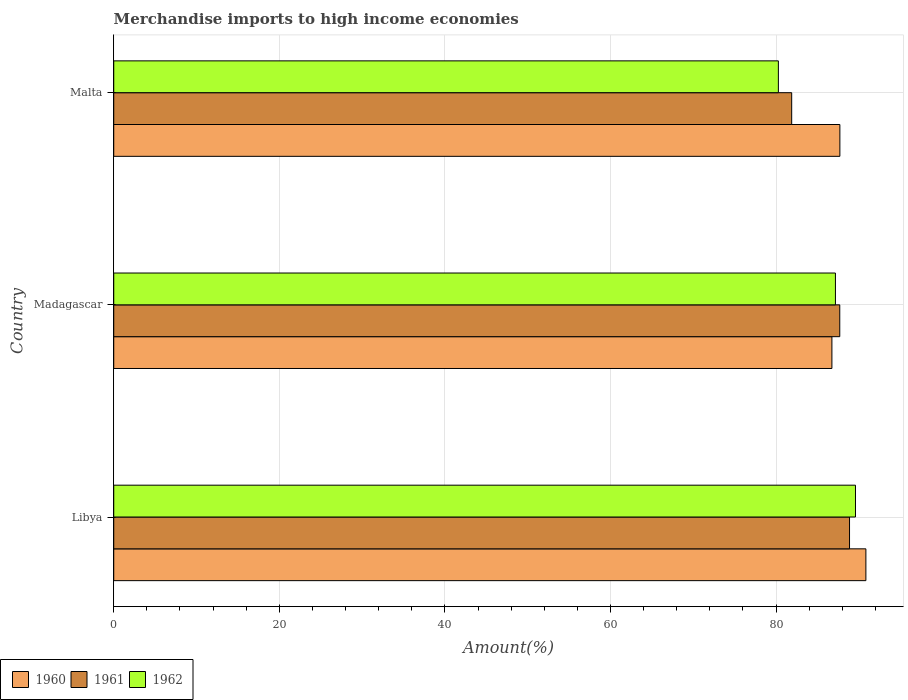Are the number of bars per tick equal to the number of legend labels?
Make the answer very short. Yes. Are the number of bars on each tick of the Y-axis equal?
Your answer should be compact. Yes. How many bars are there on the 2nd tick from the bottom?
Offer a very short reply. 3. What is the label of the 2nd group of bars from the top?
Your answer should be very brief. Madagascar. In how many cases, is the number of bars for a given country not equal to the number of legend labels?
Offer a very short reply. 0. What is the percentage of amount earned from merchandise imports in 1962 in Malta?
Make the answer very short. 80.28. Across all countries, what is the maximum percentage of amount earned from merchandise imports in 1961?
Offer a very short reply. 88.87. Across all countries, what is the minimum percentage of amount earned from merchandise imports in 1962?
Provide a short and direct response. 80.28. In which country was the percentage of amount earned from merchandise imports in 1960 maximum?
Keep it short and to the point. Libya. In which country was the percentage of amount earned from merchandise imports in 1961 minimum?
Make the answer very short. Malta. What is the total percentage of amount earned from merchandise imports in 1962 in the graph?
Offer a very short reply. 257.04. What is the difference between the percentage of amount earned from merchandise imports in 1960 in Libya and that in Malta?
Make the answer very short. 3.14. What is the difference between the percentage of amount earned from merchandise imports in 1960 in Malta and the percentage of amount earned from merchandise imports in 1962 in Libya?
Ensure brevity in your answer.  -1.88. What is the average percentage of amount earned from merchandise imports in 1961 per country?
Your response must be concise. 86.15. What is the difference between the percentage of amount earned from merchandise imports in 1960 and percentage of amount earned from merchandise imports in 1961 in Madagascar?
Ensure brevity in your answer.  -0.95. What is the ratio of the percentage of amount earned from merchandise imports in 1960 in Libya to that in Malta?
Your answer should be compact. 1.04. Is the percentage of amount earned from merchandise imports in 1960 in Libya less than that in Madagascar?
Ensure brevity in your answer.  No. What is the difference between the highest and the second highest percentage of amount earned from merchandise imports in 1961?
Make the answer very short. 1.18. What is the difference between the highest and the lowest percentage of amount earned from merchandise imports in 1961?
Offer a terse response. 6.99. In how many countries, is the percentage of amount earned from merchandise imports in 1960 greater than the average percentage of amount earned from merchandise imports in 1960 taken over all countries?
Make the answer very short. 1. What does the 1st bar from the top in Libya represents?
Provide a short and direct response. 1962. Is it the case that in every country, the sum of the percentage of amount earned from merchandise imports in 1961 and percentage of amount earned from merchandise imports in 1960 is greater than the percentage of amount earned from merchandise imports in 1962?
Provide a short and direct response. Yes. How many bars are there?
Make the answer very short. 9. Are all the bars in the graph horizontal?
Give a very brief answer. Yes. How many countries are there in the graph?
Your response must be concise. 3. What is the difference between two consecutive major ticks on the X-axis?
Give a very brief answer. 20. Are the values on the major ticks of X-axis written in scientific E-notation?
Offer a very short reply. No. Does the graph contain any zero values?
Your answer should be compact. No. Does the graph contain grids?
Keep it short and to the point. Yes. Where does the legend appear in the graph?
Offer a very short reply. Bottom left. How many legend labels are there?
Offer a very short reply. 3. How are the legend labels stacked?
Provide a succinct answer. Horizontal. What is the title of the graph?
Make the answer very short. Merchandise imports to high income economies. What is the label or title of the X-axis?
Keep it short and to the point. Amount(%). What is the label or title of the Y-axis?
Your response must be concise. Country. What is the Amount(%) of 1960 in Libya?
Keep it short and to the point. 90.85. What is the Amount(%) in 1961 in Libya?
Make the answer very short. 88.87. What is the Amount(%) of 1962 in Libya?
Your answer should be compact. 89.59. What is the Amount(%) of 1960 in Madagascar?
Your answer should be very brief. 86.74. What is the Amount(%) of 1961 in Madagascar?
Provide a short and direct response. 87.69. What is the Amount(%) of 1962 in Madagascar?
Your response must be concise. 87.17. What is the Amount(%) in 1960 in Malta?
Give a very brief answer. 87.71. What is the Amount(%) in 1961 in Malta?
Give a very brief answer. 81.89. What is the Amount(%) in 1962 in Malta?
Your response must be concise. 80.28. Across all countries, what is the maximum Amount(%) of 1960?
Offer a very short reply. 90.85. Across all countries, what is the maximum Amount(%) of 1961?
Keep it short and to the point. 88.87. Across all countries, what is the maximum Amount(%) in 1962?
Your answer should be very brief. 89.59. Across all countries, what is the minimum Amount(%) in 1960?
Make the answer very short. 86.74. Across all countries, what is the minimum Amount(%) of 1961?
Your response must be concise. 81.89. Across all countries, what is the minimum Amount(%) of 1962?
Ensure brevity in your answer.  80.28. What is the total Amount(%) of 1960 in the graph?
Keep it short and to the point. 265.3. What is the total Amount(%) in 1961 in the graph?
Keep it short and to the point. 258.45. What is the total Amount(%) in 1962 in the graph?
Make the answer very short. 257.04. What is the difference between the Amount(%) of 1960 in Libya and that in Madagascar?
Give a very brief answer. 4.1. What is the difference between the Amount(%) in 1961 in Libya and that in Madagascar?
Your answer should be compact. 1.18. What is the difference between the Amount(%) in 1962 in Libya and that in Madagascar?
Keep it short and to the point. 2.42. What is the difference between the Amount(%) in 1960 in Libya and that in Malta?
Offer a terse response. 3.14. What is the difference between the Amount(%) of 1961 in Libya and that in Malta?
Your answer should be compact. 6.99. What is the difference between the Amount(%) of 1962 in Libya and that in Malta?
Offer a very short reply. 9.31. What is the difference between the Amount(%) in 1960 in Madagascar and that in Malta?
Keep it short and to the point. -0.96. What is the difference between the Amount(%) in 1961 in Madagascar and that in Malta?
Ensure brevity in your answer.  5.81. What is the difference between the Amount(%) of 1962 in Madagascar and that in Malta?
Make the answer very short. 6.89. What is the difference between the Amount(%) in 1960 in Libya and the Amount(%) in 1961 in Madagascar?
Your response must be concise. 3.15. What is the difference between the Amount(%) of 1960 in Libya and the Amount(%) of 1962 in Madagascar?
Your answer should be compact. 3.68. What is the difference between the Amount(%) in 1961 in Libya and the Amount(%) in 1962 in Madagascar?
Keep it short and to the point. 1.7. What is the difference between the Amount(%) in 1960 in Libya and the Amount(%) in 1961 in Malta?
Give a very brief answer. 8.96. What is the difference between the Amount(%) of 1960 in Libya and the Amount(%) of 1962 in Malta?
Provide a short and direct response. 10.57. What is the difference between the Amount(%) of 1961 in Libya and the Amount(%) of 1962 in Malta?
Keep it short and to the point. 8.6. What is the difference between the Amount(%) in 1960 in Madagascar and the Amount(%) in 1961 in Malta?
Offer a very short reply. 4.86. What is the difference between the Amount(%) in 1960 in Madagascar and the Amount(%) in 1962 in Malta?
Provide a short and direct response. 6.47. What is the difference between the Amount(%) of 1961 in Madagascar and the Amount(%) of 1962 in Malta?
Your answer should be compact. 7.42. What is the average Amount(%) in 1960 per country?
Make the answer very short. 88.43. What is the average Amount(%) of 1961 per country?
Provide a short and direct response. 86.15. What is the average Amount(%) of 1962 per country?
Keep it short and to the point. 85.68. What is the difference between the Amount(%) in 1960 and Amount(%) in 1961 in Libya?
Provide a short and direct response. 1.97. What is the difference between the Amount(%) of 1960 and Amount(%) of 1962 in Libya?
Provide a succinct answer. 1.26. What is the difference between the Amount(%) in 1961 and Amount(%) in 1962 in Libya?
Your answer should be compact. -0.72. What is the difference between the Amount(%) of 1960 and Amount(%) of 1961 in Madagascar?
Your answer should be very brief. -0.95. What is the difference between the Amount(%) of 1960 and Amount(%) of 1962 in Madagascar?
Keep it short and to the point. -0.43. What is the difference between the Amount(%) in 1961 and Amount(%) in 1962 in Madagascar?
Provide a succinct answer. 0.52. What is the difference between the Amount(%) of 1960 and Amount(%) of 1961 in Malta?
Keep it short and to the point. 5.82. What is the difference between the Amount(%) of 1960 and Amount(%) of 1962 in Malta?
Make the answer very short. 7.43. What is the difference between the Amount(%) in 1961 and Amount(%) in 1962 in Malta?
Offer a very short reply. 1.61. What is the ratio of the Amount(%) of 1960 in Libya to that in Madagascar?
Offer a very short reply. 1.05. What is the ratio of the Amount(%) of 1961 in Libya to that in Madagascar?
Offer a terse response. 1.01. What is the ratio of the Amount(%) of 1962 in Libya to that in Madagascar?
Provide a succinct answer. 1.03. What is the ratio of the Amount(%) of 1960 in Libya to that in Malta?
Offer a terse response. 1.04. What is the ratio of the Amount(%) in 1961 in Libya to that in Malta?
Offer a very short reply. 1.09. What is the ratio of the Amount(%) in 1962 in Libya to that in Malta?
Ensure brevity in your answer.  1.12. What is the ratio of the Amount(%) in 1960 in Madagascar to that in Malta?
Offer a very short reply. 0.99. What is the ratio of the Amount(%) in 1961 in Madagascar to that in Malta?
Offer a terse response. 1.07. What is the ratio of the Amount(%) in 1962 in Madagascar to that in Malta?
Your answer should be very brief. 1.09. What is the difference between the highest and the second highest Amount(%) of 1960?
Ensure brevity in your answer.  3.14. What is the difference between the highest and the second highest Amount(%) in 1961?
Keep it short and to the point. 1.18. What is the difference between the highest and the second highest Amount(%) in 1962?
Make the answer very short. 2.42. What is the difference between the highest and the lowest Amount(%) of 1960?
Your answer should be very brief. 4.1. What is the difference between the highest and the lowest Amount(%) in 1961?
Keep it short and to the point. 6.99. What is the difference between the highest and the lowest Amount(%) in 1962?
Keep it short and to the point. 9.31. 